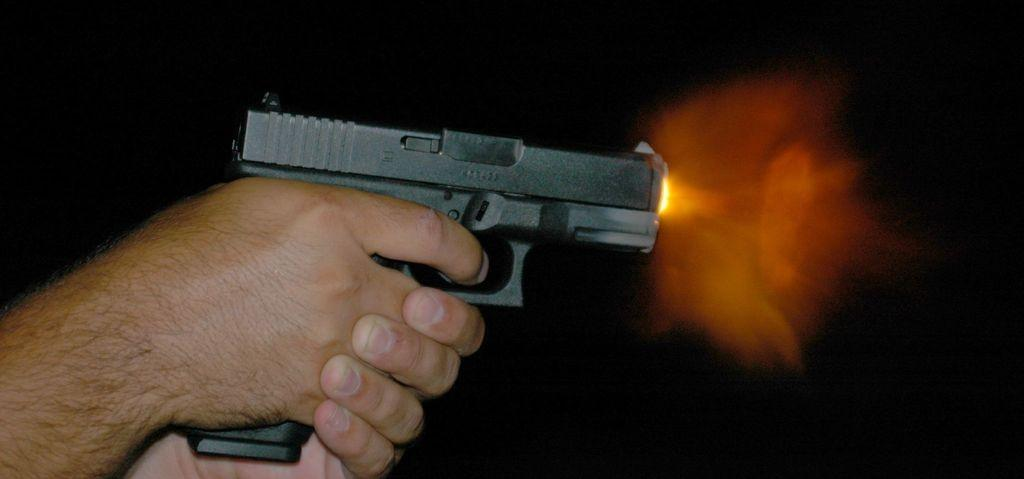What object is being held by the person's hands in the image? A black color gun is being held by the person's hands in the image. What colors can be seen in the image? There are black and orange colors present in the image. How does the person in the image tax their muscles? There is no mention of taxing muscles or any tax-related activity in the image. 